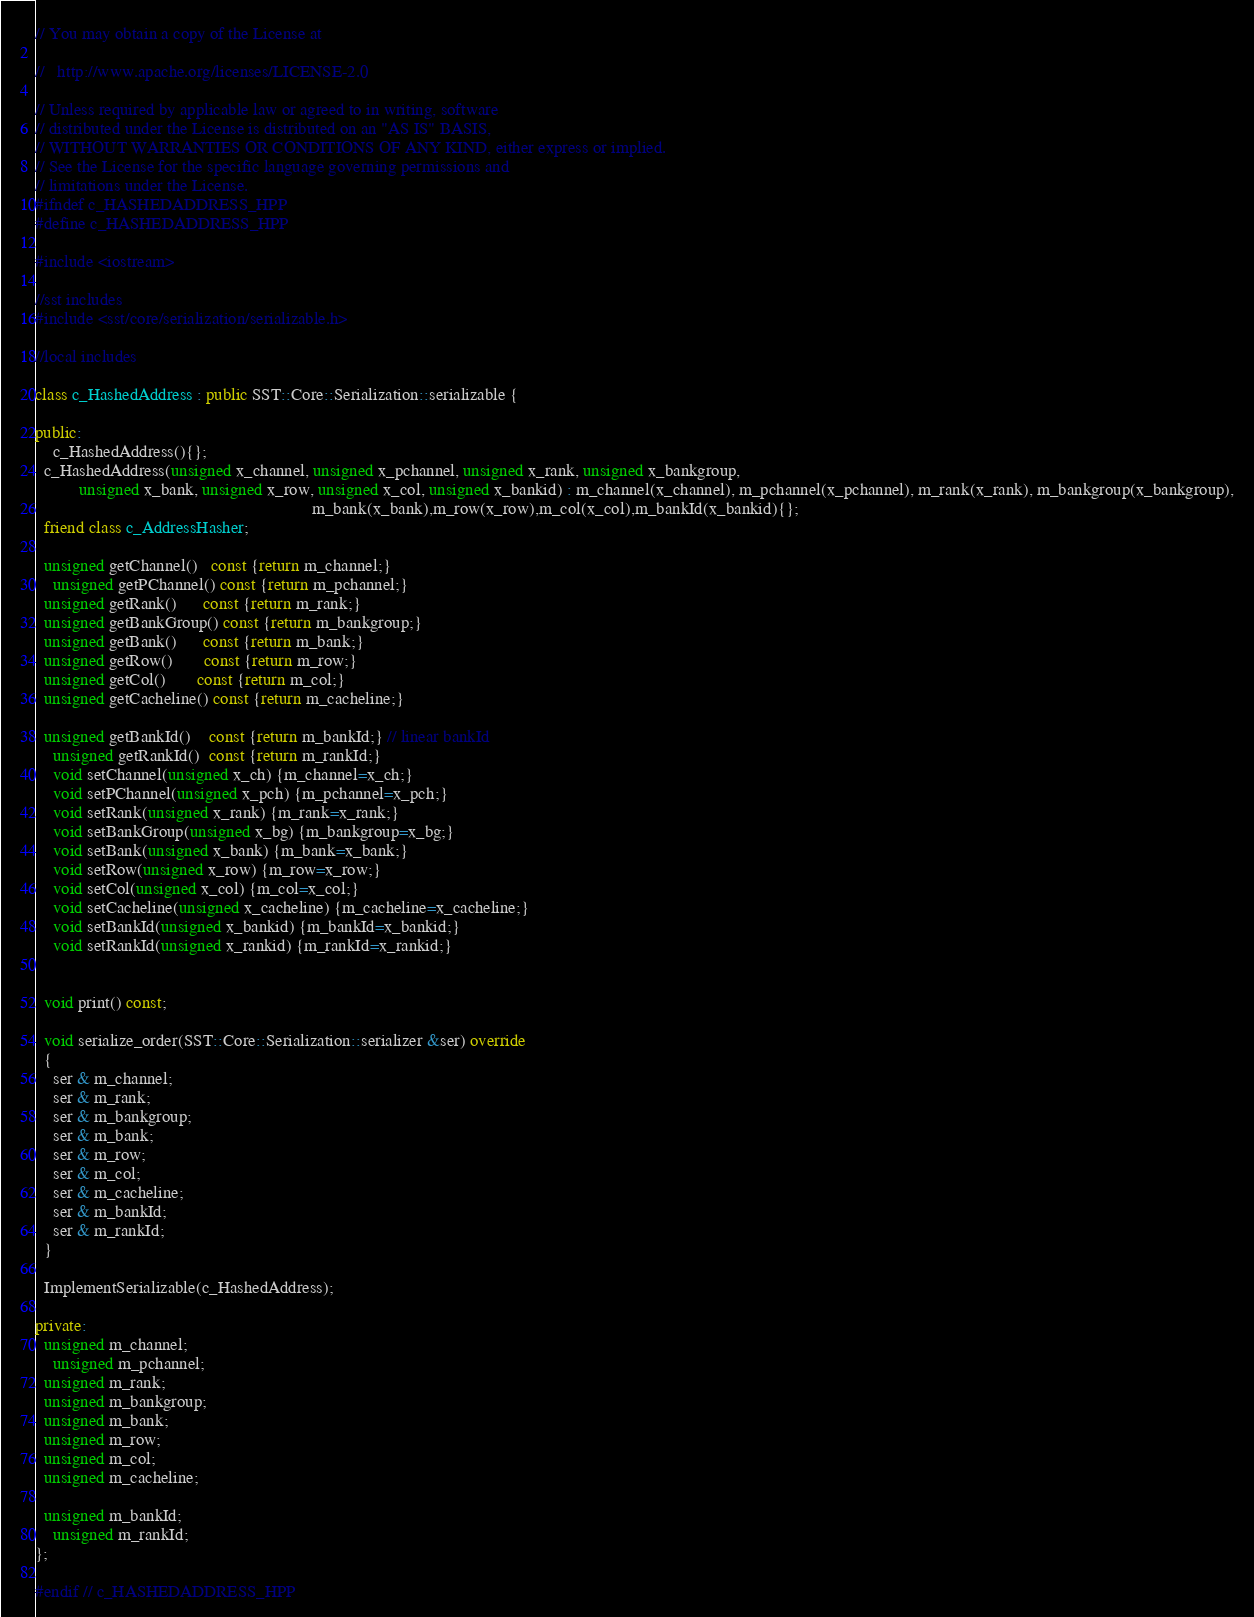Convert code to text. <code><loc_0><loc_0><loc_500><loc_500><_C++_>// You may obtain a copy of the License at

//   http://www.apache.org/licenses/LICENSE-2.0

// Unless required by applicable law or agreed to in writing, software
// distributed under the License is distributed on an "AS IS" BASIS,
// WITHOUT WARRANTIES OR CONDITIONS OF ANY KIND, either express or implied.
// See the License for the specific language governing permissions and
// limitations under the License.
#ifndef c_HASHEDADDRESS_HPP
#define c_HASHEDADDRESS_HPP

#include <iostream>

//sst includes
#include <sst/core/serialization/serializable.h>

//local includes

class c_HashedAddress : public SST::Core::Serialization::serializable {

public:
    c_HashedAddress(){};
  c_HashedAddress(unsigned x_channel, unsigned x_pchannel, unsigned x_rank, unsigned x_bankgroup,
  		  unsigned x_bank, unsigned x_row, unsigned x_col, unsigned x_bankid) : m_channel(x_channel), m_pchannel(x_pchannel), m_rank(x_rank), m_bankgroup(x_bankgroup),
                                                               m_bank(x_bank),m_row(x_row),m_col(x_col),m_bankId(x_bankid){};
  friend class c_AddressHasher;
  
  unsigned getChannel()   const {return m_channel;}
    unsigned getPChannel() const {return m_pchannel;}
  unsigned getRank()      const {return m_rank;}
  unsigned getBankGroup() const {return m_bankgroup;}
  unsigned getBank()      const {return m_bank;}
  unsigned getRow()       const {return m_row;}
  unsigned getCol()       const {return m_col;}
  unsigned getCacheline() const {return m_cacheline;}

  unsigned getBankId()    const {return m_bankId;} // linear bankId
    unsigned getRankId()  const {return m_rankId;}
    void setChannel(unsigned x_ch) {m_channel=x_ch;}
    void setPChannel(unsigned x_pch) {m_pchannel=x_pch;}
    void setRank(unsigned x_rank) {m_rank=x_rank;}
    void setBankGroup(unsigned x_bg) {m_bankgroup=x_bg;}
    void setBank(unsigned x_bank) {m_bank=x_bank;}
    void setRow(unsigned x_row) {m_row=x_row;}
    void setCol(unsigned x_col) {m_col=x_col;}
    void setCacheline(unsigned x_cacheline) {m_cacheline=x_cacheline;}
    void setBankId(unsigned x_bankid) {m_bankId=x_bankid;}
    void setRankId(unsigned x_rankid) {m_rankId=x_rankid;}


  void print() const;
  
  void serialize_order(SST::Core::Serialization::serializer &ser) override
  {
    ser & m_channel;
    ser & m_rank;
    ser & m_bankgroup;
    ser & m_bank;
    ser & m_row;
    ser & m_col;
    ser & m_cacheline;
    ser & m_bankId;
    ser & m_rankId;
  }
  
  ImplementSerializable(c_HashedAddress);

private:
  unsigned m_channel;
    unsigned m_pchannel;
  unsigned m_rank;
  unsigned m_bankgroup;
  unsigned m_bank;
  unsigned m_row;
  unsigned m_col;
  unsigned m_cacheline;

  unsigned m_bankId;
    unsigned m_rankId;
};

#endif // c_HASHEDADDRESS_HPP
</code> 